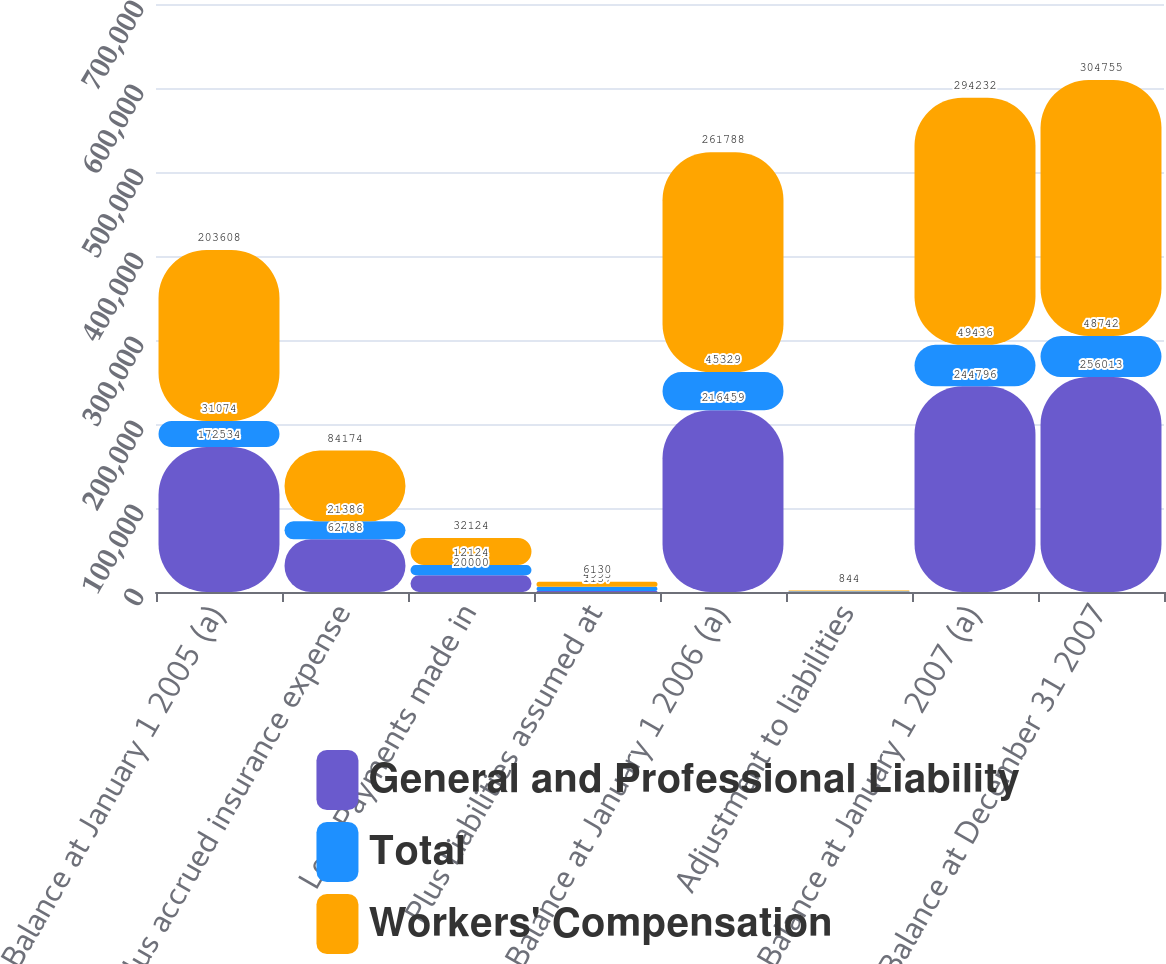Convert chart to OTSL. <chart><loc_0><loc_0><loc_500><loc_500><stacked_bar_chart><ecel><fcel>Balance at January 1 2005 (a)<fcel>Plus accrued insurance expense<fcel>Less Payments made in<fcel>Plus Liabilities assumed at<fcel>Balance at January 1 2006 (a)<fcel>Adjustment to liabilities<fcel>Balance at January 1 2007 (a)<fcel>Balance at December 31 2007<nl><fcel>General and Professional Liability<fcel>172534<fcel>62788<fcel>20000<fcel>1137<fcel>216459<fcel>176<fcel>244796<fcel>256013<nl><fcel>Total<fcel>31074<fcel>21386<fcel>12124<fcel>4993<fcel>45329<fcel>668<fcel>49436<fcel>48742<nl><fcel>Workers' Compensation<fcel>203608<fcel>84174<fcel>32124<fcel>6130<fcel>261788<fcel>844<fcel>294232<fcel>304755<nl></chart> 